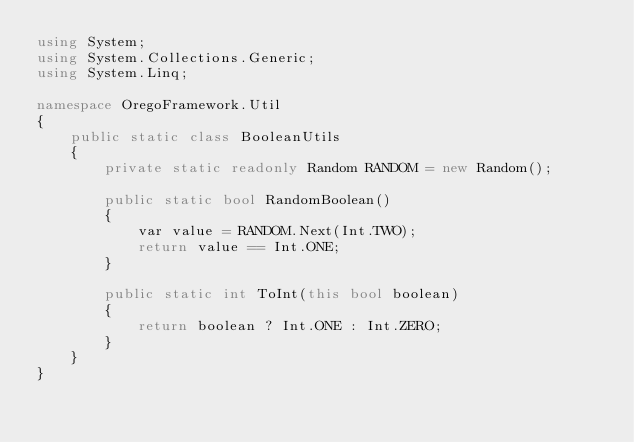Convert code to text. <code><loc_0><loc_0><loc_500><loc_500><_C#_>using System;
using System.Collections.Generic;
using System.Linq;

namespace OregoFramework.Util
{
    public static class BooleanUtils
    {
        private static readonly Random RANDOM = new Random();
        
        public static bool RandomBoolean()
        {
            var value = RANDOM.Next(Int.TWO);
            return value == Int.ONE;
        }
        
        public static int ToInt(this bool boolean)
        {
            return boolean ? Int.ONE : Int.ZERO;
        }
    }
}</code> 